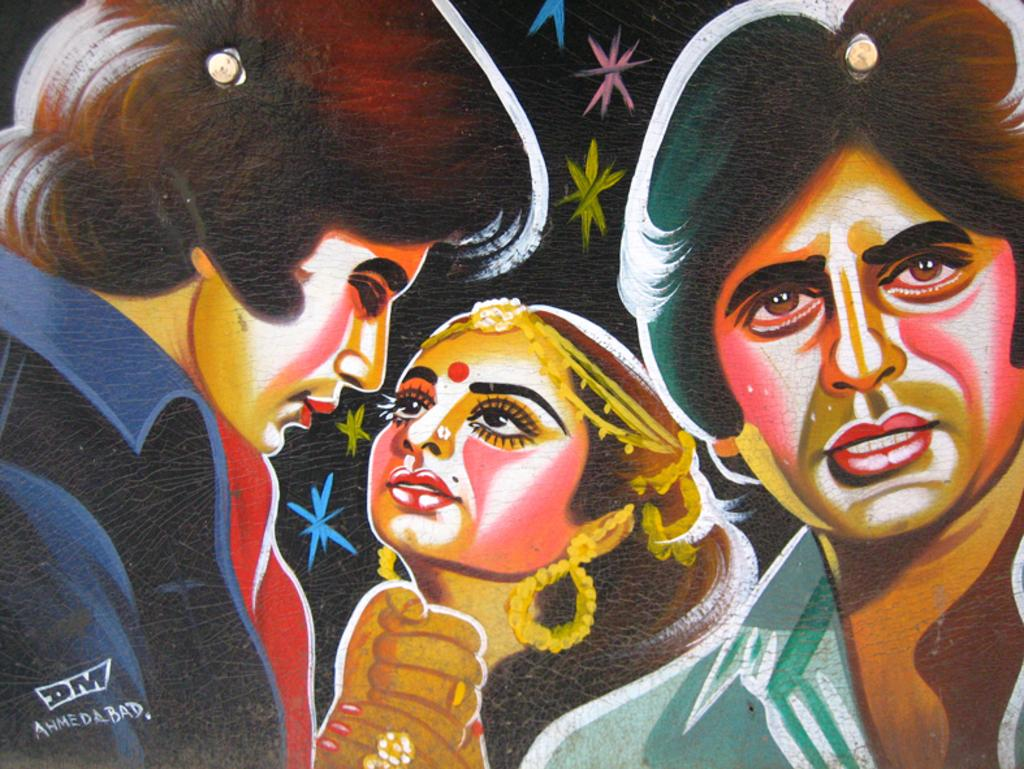What is the main subject of the image? The main subject of the image is a painting. What is depicted in the painting? The painting depicts three persons. Are there any words or letters in the image? Yes, there is text in the image. What month is depicted in the painting? The painting does not depict a month; it depicts three persons. Can you see a plane in the painting? There is no plane present in the painting; it only depicts three persons. 